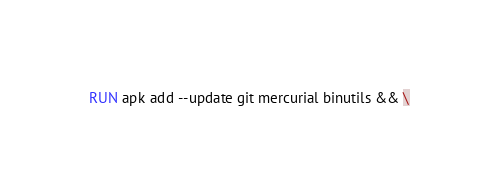Convert code to text. <code><loc_0><loc_0><loc_500><loc_500><_Dockerfile_>
RUN apk add --update git mercurial binutils && \</code> 